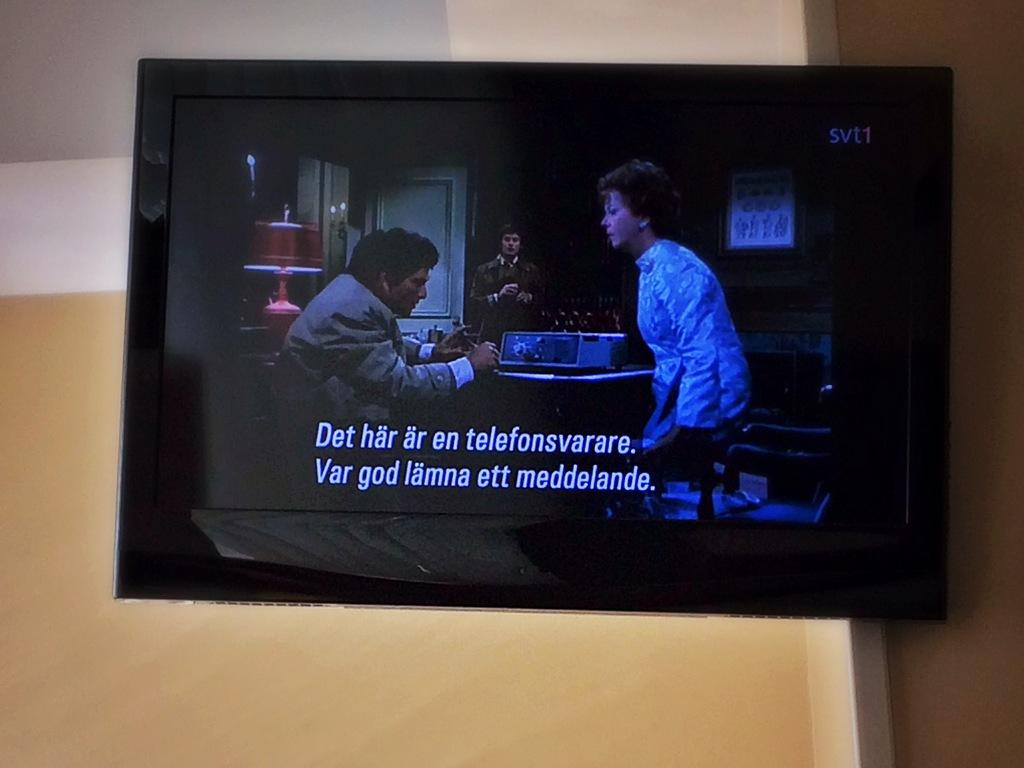What electronic device is visible in the image? There is a TV in the image. Where is the TV located in the image? The TV is on the wall. What part of the image does the TV occupy? The TV is in the foreground of the image. What type of fish is depicted on the canvas in the image? There is no canvas or fish present in the image; it features a TV on the wall. 